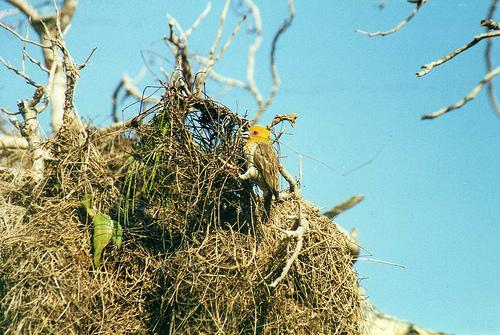Choose one aspect of the image and explain why you find it appealing or interesting. I find the bird's vibrant yellow head interesting, as it stands out among the brown surroundings and adds a touch of brightness to the entire scene. Mention the main object of the image and one of its features that would potentially catch the viewer's attention. The main object of the image is the bird with a distinctively bright yellow head, which captures the viewer's attention with its contrasting color. Compose a short poem inspired by the scenery in the image. In a sky where clouds are not allowed. Relate the image's content to a message about the importance of protecting nature. This image of the bird in its nest, surrounded by dried grasses and tree branches, highlights the beauty and serenity of nature. It serves as a reminder to protect our natural habitats to ensure that future generations of birds can thrive in harmony with the environment. Imagine you are the bird in this image. Describe the view from your perspective. As the bird, I see a nest made of dried grass and branches beneath me. Around me are brown and green grasses, and above me is a vast, clear blue sky that stretches infinitely. Explain the main colors you can see in the image and how they interact with each other. The main colors are yellow on the bird's head, brown on its body and surrounding elements, and clear light blue for the sky. These colors create a harmonious and natural scene with a warm and calm atmosphere. Based on the image, list three elements that make this scene visually engaging. 3. The detailed texture of the nest and its surroundings. Describe the environment where the bird is situated in the image. The bird is in an environment with dried brown grass, tree branches, and a clear blue sky. There are some green grasses around and a green leaf in the nest. Create an advertising slogan for a brand using elements from the image. "Experience nature's embrace with Bird's Nest Comforts - the perfect bedding for those who long for the calm of the wild." Study the image and identify the primary object, its color, and its surroundings. The primary object is a bird with a yellow head and brown body, sitting in a nest surrounded by dried grass, tree branches, and a clear blue sky. 